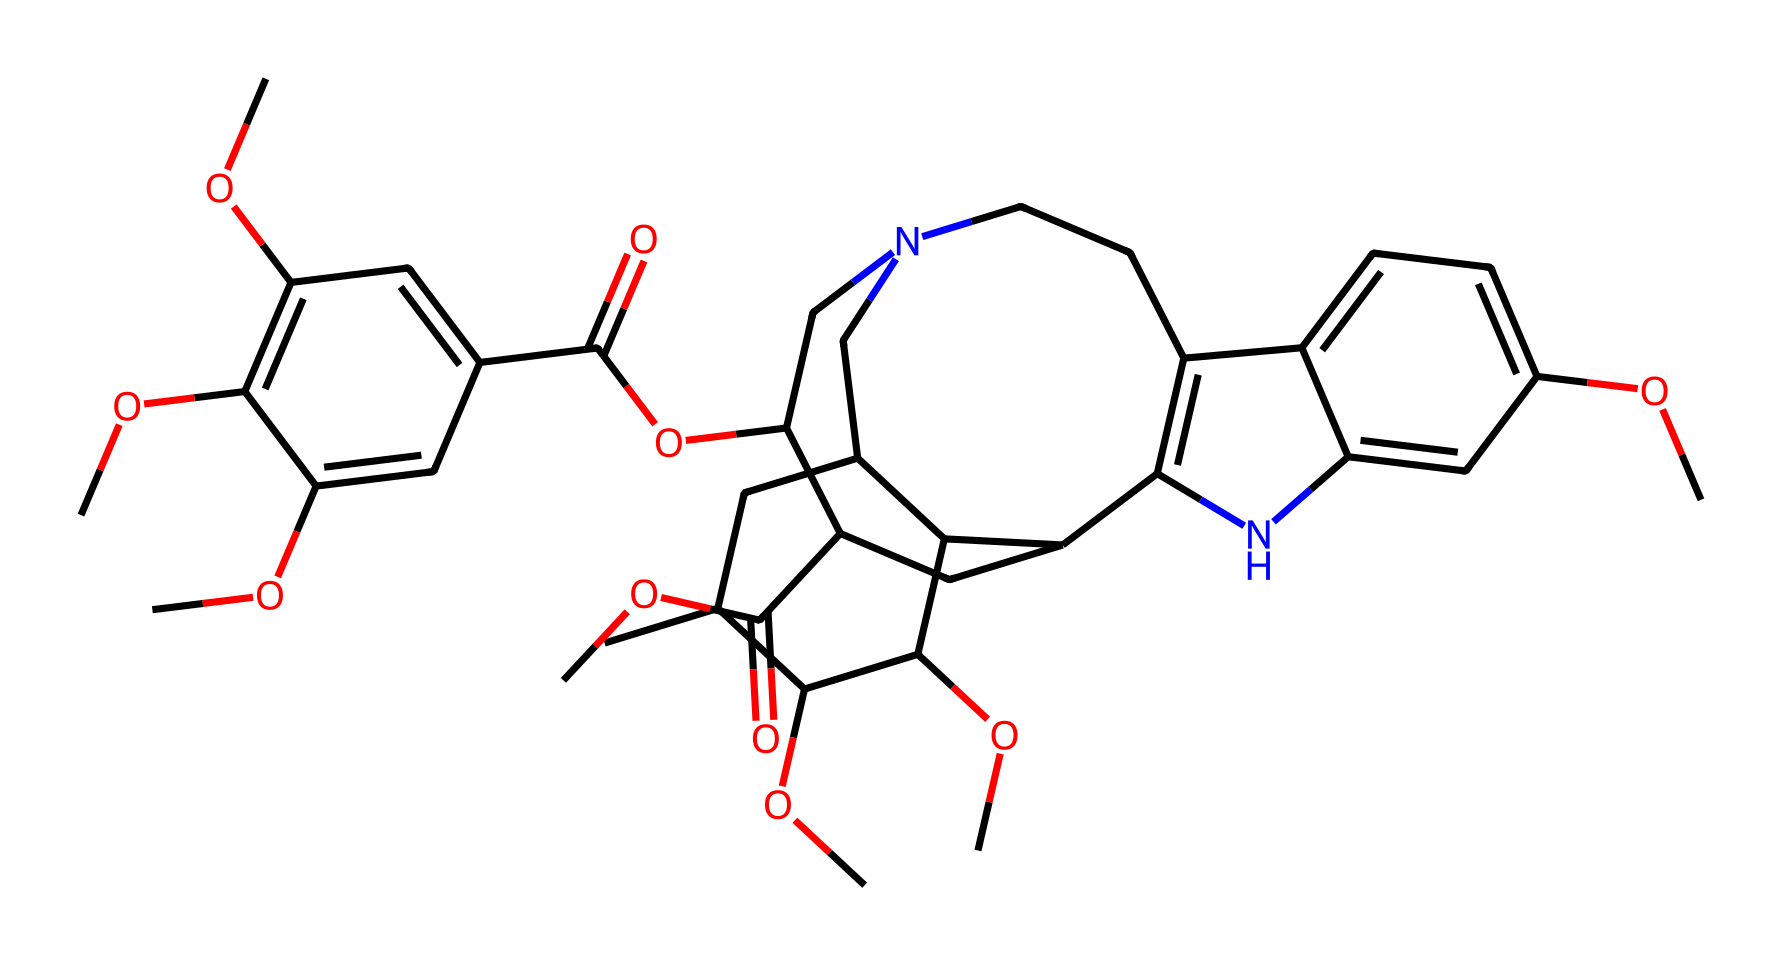What is the molecular formula of reserpine? To determine the molecular formula, you analyze the SMILES representation for the count of each atom type. In the provided SMILES, the composition includes Carbon (C), Hydrogen (H), Oxygen (O), and Nitrogen (N). After breaking down the structure, the count is found to be C23, H30, N2, O5.
Answer: C23H30N2O5 How many rings are present in the reserpine structure? By examining the SMILES notation, the ring structures can be identified, which are indicated by numbers (1, 2, etc.) that denote the start and end of a ring. Counting these from the SMILES shows that there are four distinct ring systems.
Answer: 4 What functional groups are present in reserpine? Analyzing the SMILES reveals the presence of multiple functional groups, including methoxy groups (-OCH3) and an ester group (-COOR). Recognizing these components allows us to identify the functional groups.
Answer: methoxy, ester Which atom in reserpine is responsible for its pharmacological activity? Looking closely at the chemical structure, it is the nitrogen atoms which are part of the nitrogen-containing heterocycles, common in alkaloids, that provide the pharmacological activity, enabling interaction with biological receptors.
Answer: nitrogen How many chiral centers does reserpine have? A chiral center in a molecule is typically a carbon atom bonded to four different groups. When examining the structure provided by the SMILES, careful identification of such carbon atoms reveals that there are three chiral centers.
Answer: 3 What type of alkaloid is reserpine classified as? Reserpine is a type of indole alkaloid, which is evident from its structural characteristics, particularly the indole core structure present in many related compounds.
Answer: indole alkaloid 